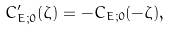<formula> <loc_0><loc_0><loc_500><loc_500>C _ { E ; 0 } ^ { \prime } ( \zeta ) = - C _ { E ; 0 } ( - \zeta ) ,</formula> 